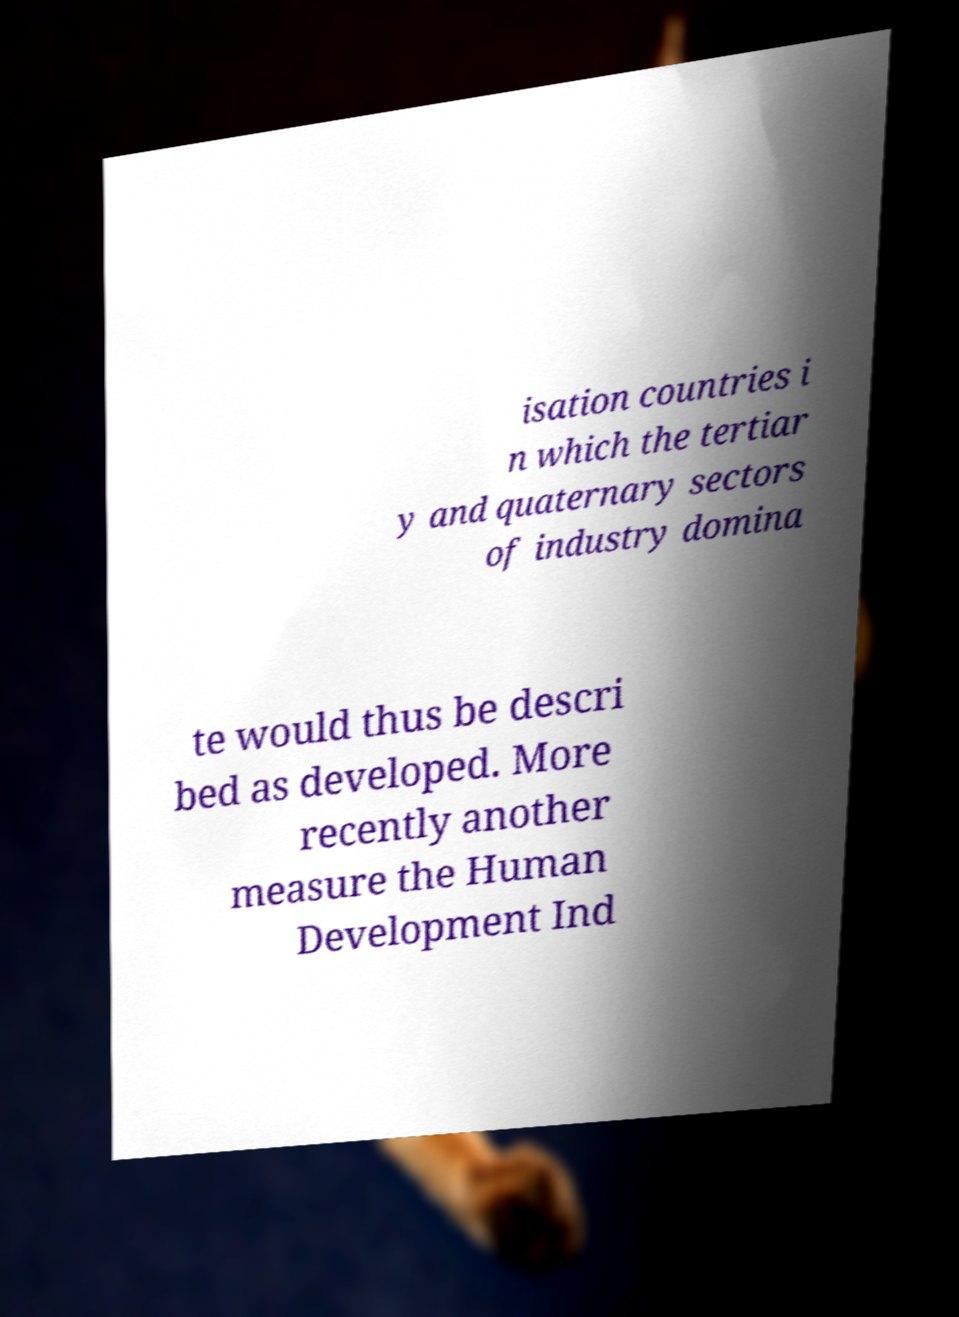Could you assist in decoding the text presented in this image and type it out clearly? isation countries i n which the tertiar y and quaternary sectors of industry domina te would thus be descri bed as developed. More recently another measure the Human Development Ind 